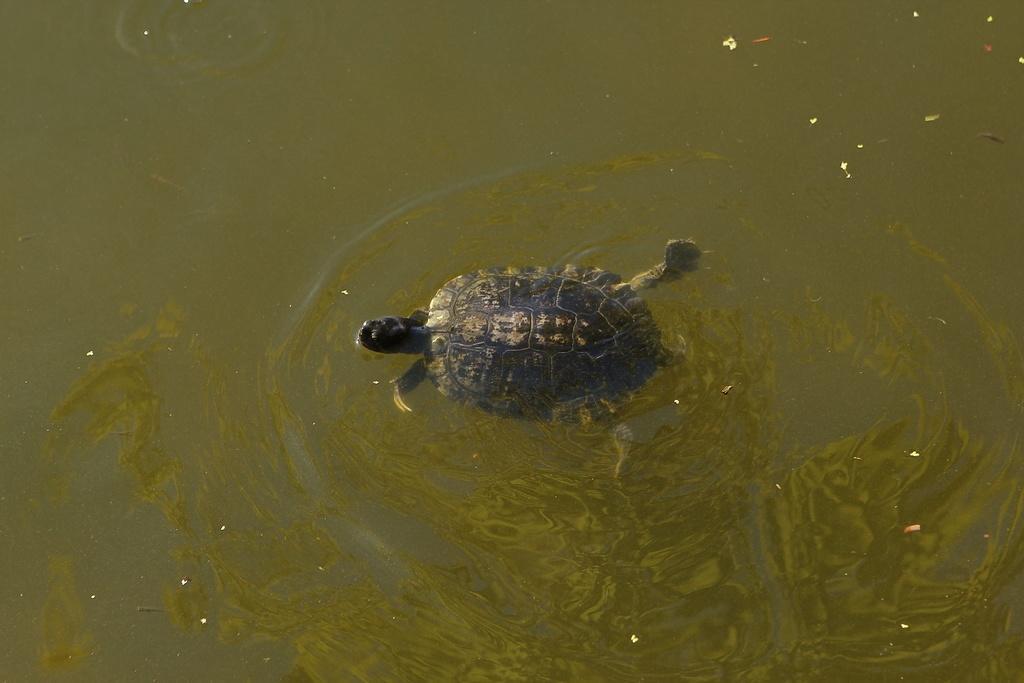Describe this image in one or two sentences. In the image we can see there is a water in which a tortoise is swimming. 